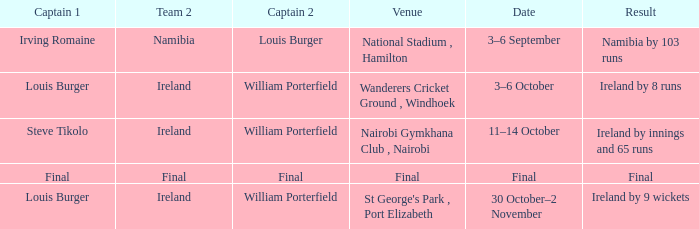Which Result has a Captain 1 of louis burger, and a Date of 30 october–2 november? Ireland by 9 wickets. 